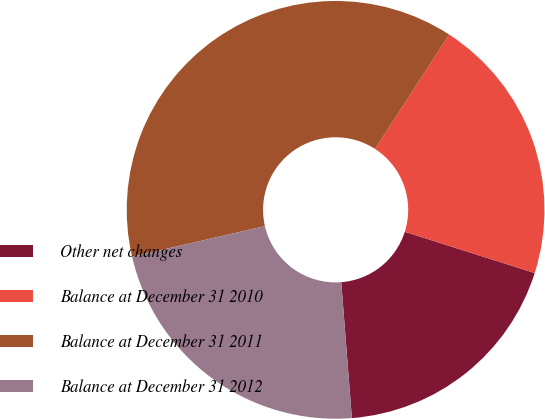<chart> <loc_0><loc_0><loc_500><loc_500><pie_chart><fcel>Other net changes<fcel>Balance at December 31 2010<fcel>Balance at December 31 2011<fcel>Balance at December 31 2012<nl><fcel>18.87%<fcel>20.75%<fcel>37.74%<fcel>22.64%<nl></chart> 